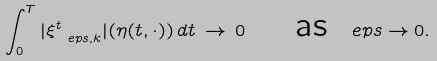<formula> <loc_0><loc_0><loc_500><loc_500>\int _ { 0 } ^ { T } | \xi _ { \ e p s , k } ^ { t } | ( \eta ( t , \cdot ) ) \, d t \, \to \, 0 \quad \text { as } \ e p s \to 0 .</formula> 